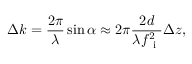<formula> <loc_0><loc_0><loc_500><loc_500>\Delta k = \frac { 2 \pi } { \lambda } \sin \alpha \approx 2 \pi \frac { 2 d } { \lambda f _ { i } ^ { 2 } } \Delta z ,</formula> 